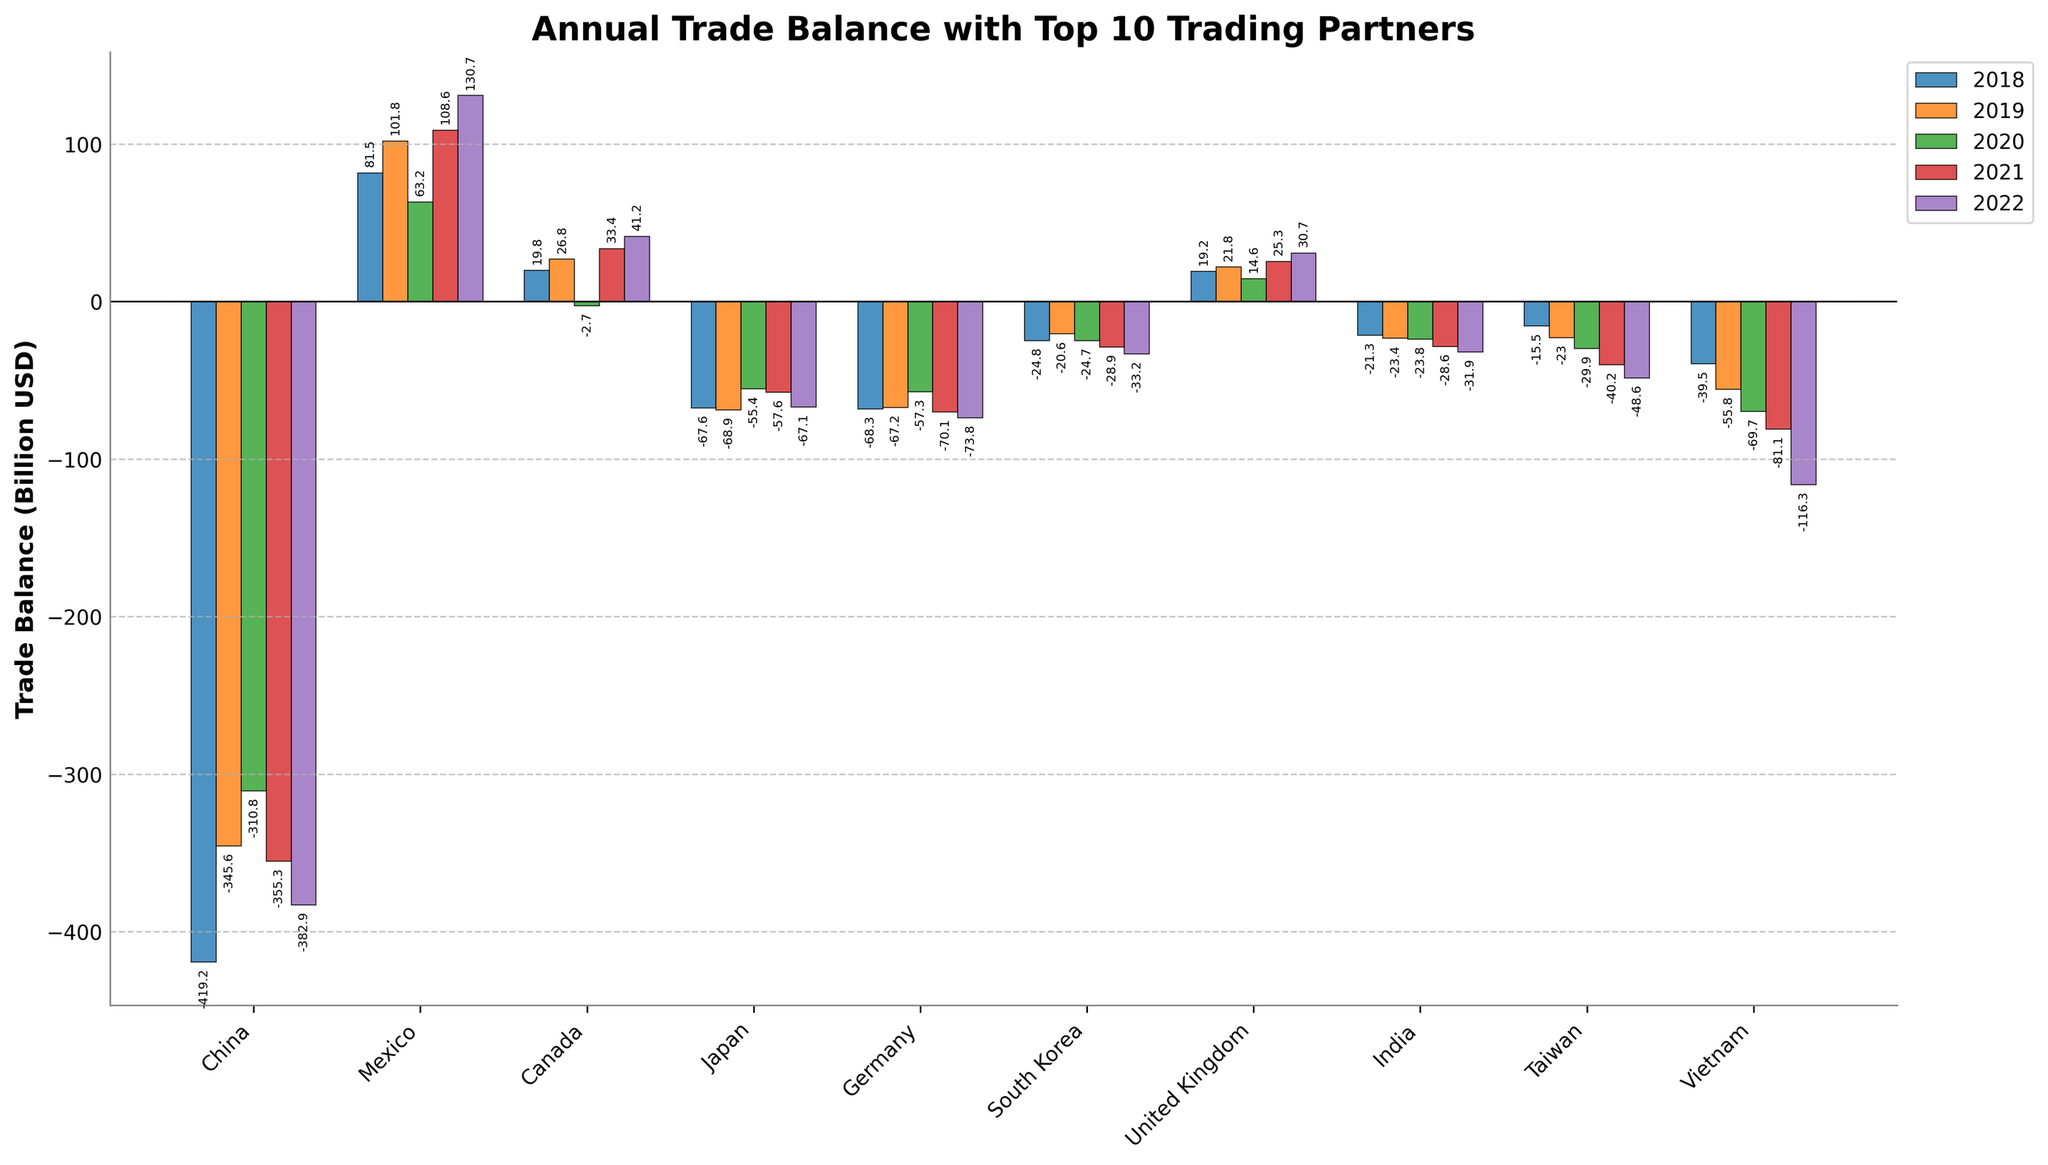What is the trade balance with China in 2020 compared to 2018? First, note the trade balance values for China in 2018 and 2020, which are -419.2 billion USD and -310.8 billion USD, respectively. The difference is -419.2 - (-310.8) = -419.2 + 310.8 = -108.4 billion USD. So, in 2020, the trade balance with China was 108.4 billion USD less negative than in 2018.
Answer: 108.4 billion USD Which country had the highest trade surplus in 2022? Observe the trade balances for 2022. The countries with a positive trade balance are Mexico (130.7 billion USD), Canada (41.2 billion USD), and United Kingdom (30.7 billion USD). Of these, Mexico has the highest trade surplus.
Answer: Mexico Did any country consistently have a negative trade balance over all five years? Check each country’s trade balance across all years. China, Japan, Germany, South Korea, India, Taiwan, and Vietnam have shown negative trade balances continuously from 2018 to 2022.
Answer: China, Japan, Germany, South Korea, India, Taiwan, Vietnam What is the total trade balance with Germany over the five years? Sum Germany's trade balances from 2018 to 2022: -68.3 + (-67.2) + (-57.3) + (-70.1) + (-73.8) = -336.7 billion USD.
Answer: -336.7 billion USD Which country showed the most improvement in trade balance from 2019 to 2020? Calculate the change in trade balance for each country between 2019 and 2020. The country with the greatest positive change is Mexico, with a difference of 63.2 - 101.8 = -38.6 billion USD improvement.
Answer: Mexico Compare the trade balance trend of Mexico and Vietnam from 2018 to 2022. Which country's trade balance improved more? For Mexico, the trade balance improved from 81.5 billion USD in 2018 to 130.7 billion USD in 2022, an increase of 49.2 billion USD. For Vietnam, it worsened from -39.5 billion USD in 2018 to -116.3 billion USD in 2022, a decrease of -76.8 billion USD. Thus, Mexico's trade balance improved more.
Answer: Mexico Which two countries had the closest trade balance values in 2019? Compare the 2019 trade balances. The closest values are China (-345.6 billion USD) and Germany (-67.2 billion USD) which have a difference in magnitude, but not direction. For opposite directions, Canada (26.8 billion USD) and United Kingdom (21.8 billion USD) are closest with a difference of 5 billion USD.
Answer: Canada and United Kingdom Visualize the overall positive and negative trade balances for 2022. Which year shows the most equitable trade distribution among these countries? Observe the bar heights and distributions for each year in the bar chart. 2021 appears to have the most bars and closest distribution between positive (Mexico, Canada, United Kingdom) and negative trade balances (China, Japan, Germany, South Korea, India, Taiwan, Vietnam).
Answer: 2021 